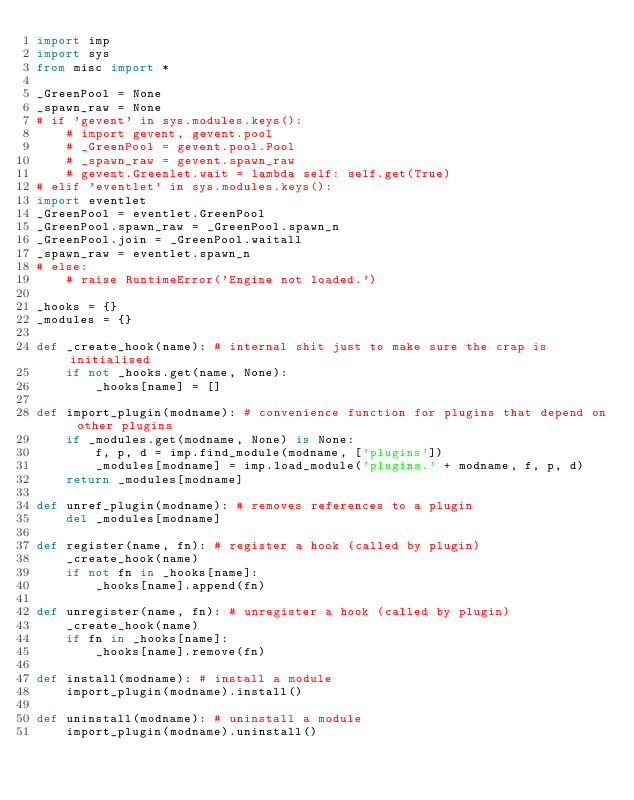Convert code to text. <code><loc_0><loc_0><loc_500><loc_500><_Python_>import imp
import sys
from misc import *

_GreenPool = None
_spawn_raw = None
# if 'gevent' in sys.modules.keys():
    # import gevent, gevent.pool
    # _GreenPool = gevent.pool.Pool
    # _spawn_raw = gevent.spawn_raw
    # gevent.Greenlet.wait = lambda self: self.get(True)
# elif 'eventlet' in sys.modules.keys():
import eventlet
_GreenPool = eventlet.GreenPool
_GreenPool.spawn_raw = _GreenPool.spawn_n
_GreenPool.join = _GreenPool.waitall
_spawn_raw = eventlet.spawn_n
# else:
    # raise RuntimeError('Engine not loaded.')

_hooks = {}
_modules = {}

def _create_hook(name): # internal shit just to make sure the crap is initialised
    if not _hooks.get(name, None):
        _hooks[name] = []

def import_plugin(modname): # convenience function for plugins that depend on other plugins
    if _modules.get(modname, None) is None:
        f, p, d = imp.find_module(modname, ['plugins'])
        _modules[modname] = imp.load_module('plugins.' + modname, f, p, d)
    return _modules[modname]
    
def unref_plugin(modname): # removes references to a plugin
    del _modules[modname]

def register(name, fn): # register a hook (called by plugin)
    _create_hook(name)
    if not fn in _hooks[name]:
        _hooks[name].append(fn)

def unregister(name, fn): # unregister a hook (called by plugin)
    _create_hook(name)
    if fn in _hooks[name]:
        _hooks[name].remove(fn)	

def install(modname): # install a module
    import_plugin(modname).install()

def uninstall(modname): # uninstall a module
    import_plugin(modname).uninstall()
</code> 